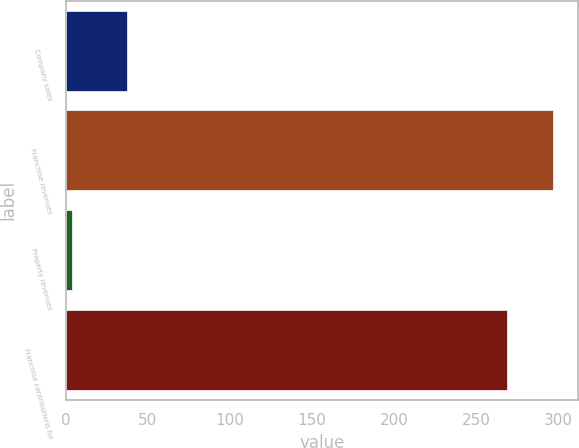Convert chart. <chart><loc_0><loc_0><loc_500><loc_500><bar_chart><fcel>Company sales<fcel>Franchise revenues<fcel>Property revenues<fcel>Franchise contributions for<nl><fcel>37<fcel>297<fcel>4<fcel>269<nl></chart> 